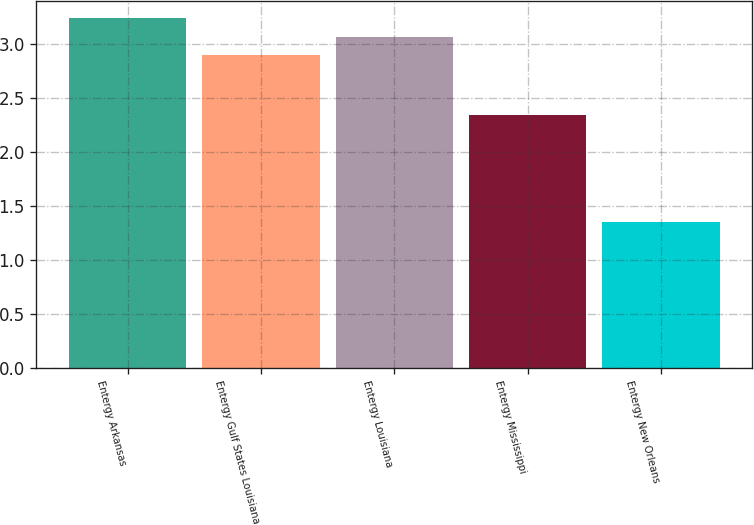Convert chart to OTSL. <chart><loc_0><loc_0><loc_500><loc_500><bar_chart><fcel>Entergy Arkansas<fcel>Entergy Gulf States Louisiana<fcel>Entergy Louisiana<fcel>Entergy Mississippi<fcel>Entergy New Orleans<nl><fcel>3.24<fcel>2.9<fcel>3.07<fcel>2.34<fcel>1.35<nl></chart> 